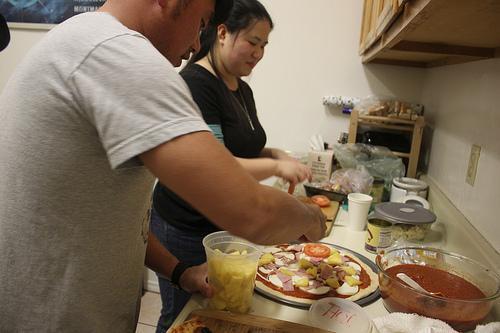How many pizzas are there?
Give a very brief answer. 1. How many people wears white t-shirts?
Give a very brief answer. 1. 